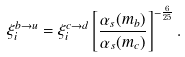<formula> <loc_0><loc_0><loc_500><loc_500>\xi _ { i } ^ { b \to u } = \xi _ { i } ^ { c \to d } \left [ \frac { \alpha _ { s } ( m _ { b } ) } { \alpha _ { s } ( m _ { c } ) } \right ] ^ { - \frac { 6 } { 2 5 } } .</formula> 